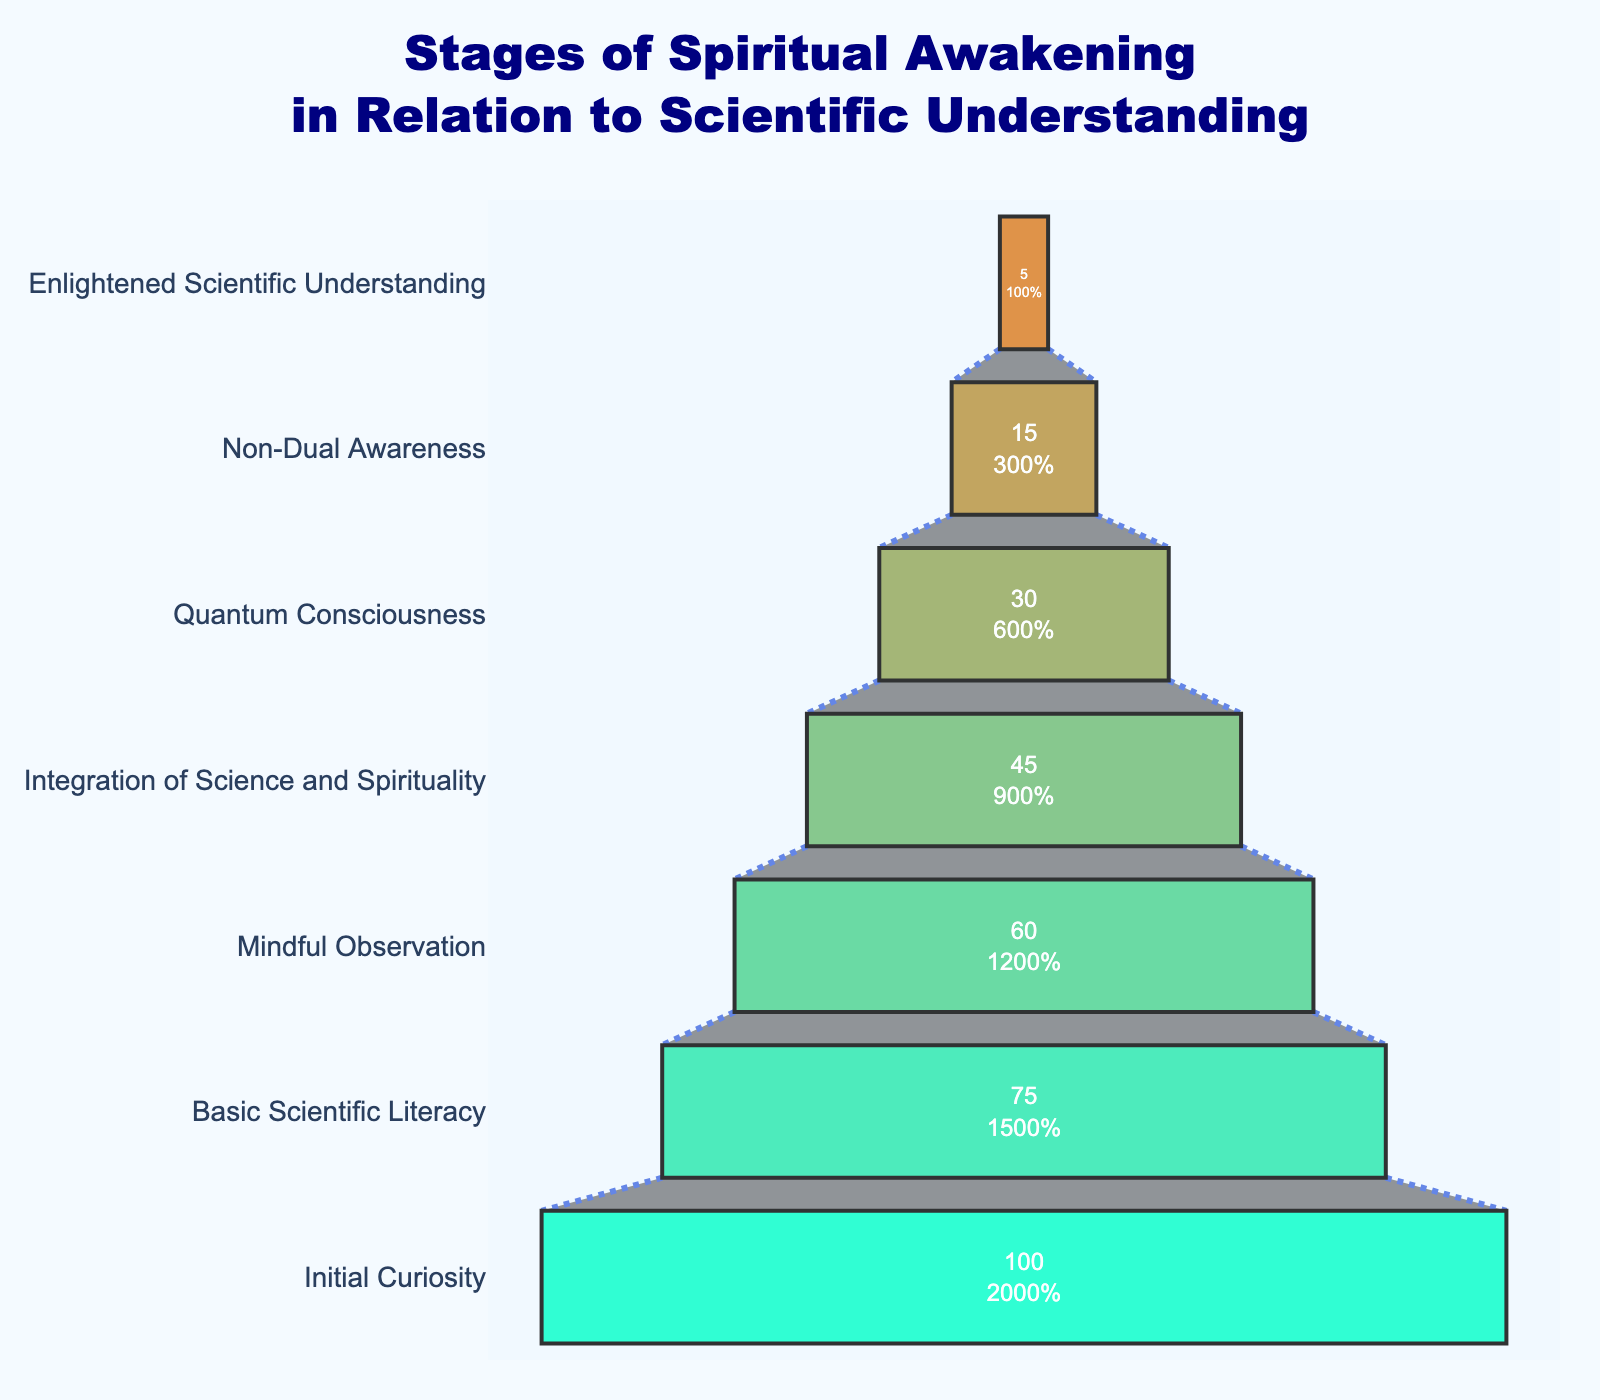What's the title of the figure? The title is positioned at the top of the figure. It reads: "Stages of Spiritual Awakening in Relation to Scientific Understanding".
Answer: Stages of Spiritual Awakening in Relation to Scientific Understanding Which stage has the highest percentage of individuals? The top section of the funnel, which is the widest, represents the stage with the highest percentage. It shows "Initial Curiosity" with 100%.
Answer: Initial Curiosity What is the percentage of individuals at the stage "Integration of Science and Spirituality"? Locate the section labeled "Integration of Science and Spirituality" on the funnel chart. The percentage associated with it is 45%.
Answer: 45% What stage directly follows "Mindful Observation" in decreasing order? In decreasing order of percentage, observe the labels. The stage that comes right after "Mindful Observation" is "Integration of Science and Spirituality".
Answer: Integration of Science and Spirituality How much lower is the percentage of individuals at "Quantum Consciousness" compared to "Basic Scientific Literacy"? "Basic Scientific Literacy" has 75%, and "Quantum Consciousness" has 30%. Subtract the percentage of "Quantum Consciousness" from "Basic Scientific Literacy" to find the difference, 75% - 30% = 45%.
Answer: 45% What is the combined percentage of individuals in the top two stages? The top two stages are "Initial Curiosity" (100%) and "Basic Scientific Literacy" (75%). Sum these percentages, 100% + 75% = 175%.
Answer: 175% Which stage has the lowest percentage of individuals, and what is that percentage? The narrowest section at the bottom of the funnel represents the stage with the lowest percentage of individuals, which is "Enlightened Scientific Understanding" with 5%.
Answer: Enlightened Scientific Understanding, 5% By how much does the percentage decrease from "Initial Curiosity" to "Mindful Observation"? "Initial Curiosity" has 100%, and "Mindful Observation" has 60%. Subtract the percentage at "Mindful Observation" from "Initial Curiosity" to find the decrease, 100% - 60% = 40%.
Answer: 40% What is the difference in percentage between "Non-Dual Awareness" and "Enlightened Scientific Understanding"? "Non-Dual Awareness" has 15%, and "Enlightened Scientific Understanding" has 5%. Subtract the percentage of "Enlightened Scientific Understanding" from "Non-Dual Awareness" to find the difference, 15% - 5% = 10%.
Answer: 10% Which two consecutive stages show the greatest percentage drop? Compare the percentage drops between each pair of consecutive stages. The pairs with their differences are: "Initial Curiosity" to "Basic Scientific Literacy" (100% - 75% = 25%), "Basic Scientific Literacy" to "Mindful Observation" (75% - 60% = 15%), "Mindful Observation" to "Integration of Science and Spirituality" (60% - 45% = 15%), "Integration of Science and Spirituality" to "Quantum Consciousness" (45% - 30% = 15%), "Quantum Consciousness" to "Non-Dual Awareness" (30% - 15% = 15%), and "Non-Dual Awareness" to "Enlightened Scientific Understanding" (15% - 5% = 10%). The greatest drop of 25% occurs between "Initial Curiosity" and "Basic Scientific Literacy".
Answer: Initial Curiosity to Basic Scientific Literacy, 25% 